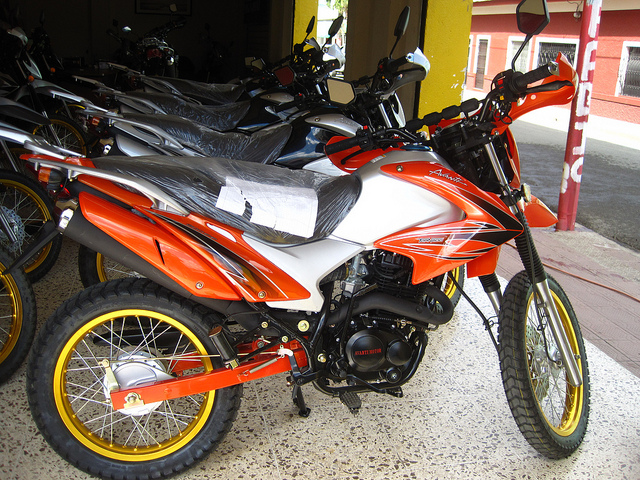Imagine the setting where this motorcycle is taken on an adventure. Describe the ride. Imagine taking this orange and white motorcycle out into the rugged terrain of a mountain trail. The sun is shining bright, and the bike's vivid colors stand out against the earthy tones of the path. As you navigate through winding trails, the motorcycle's robust build and responsive handling make every turn thrilling. You can feel the rush of the wind and hear the crunch of gravel under the tires. The journey is adventurous, the landscape picturesque, with moments that make you appreciate the powerful and agile machine you’re riding. What would you bring along for such an adventure? For an adventure ride on this motorcycle, packing light yet essential is crucial. A good quality helmet, gloves, and riding jacket are must-haves for safety. Bringing along a hydration pack, navigation tools such as a GPS or a detailed map, and a basic tool kit for any unforeseen repairs would be prudent. Additionally, pack some energy bars and a first-aid kit for emergencies. Comfortable and durable boots will keep your feet protected during the ride. 